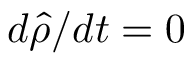Convert formula to latex. <formula><loc_0><loc_0><loc_500><loc_500>d { \hat { \rho } } / d t = 0</formula> 